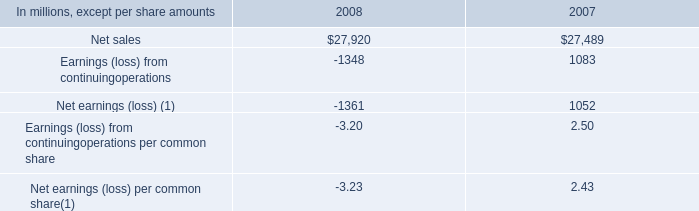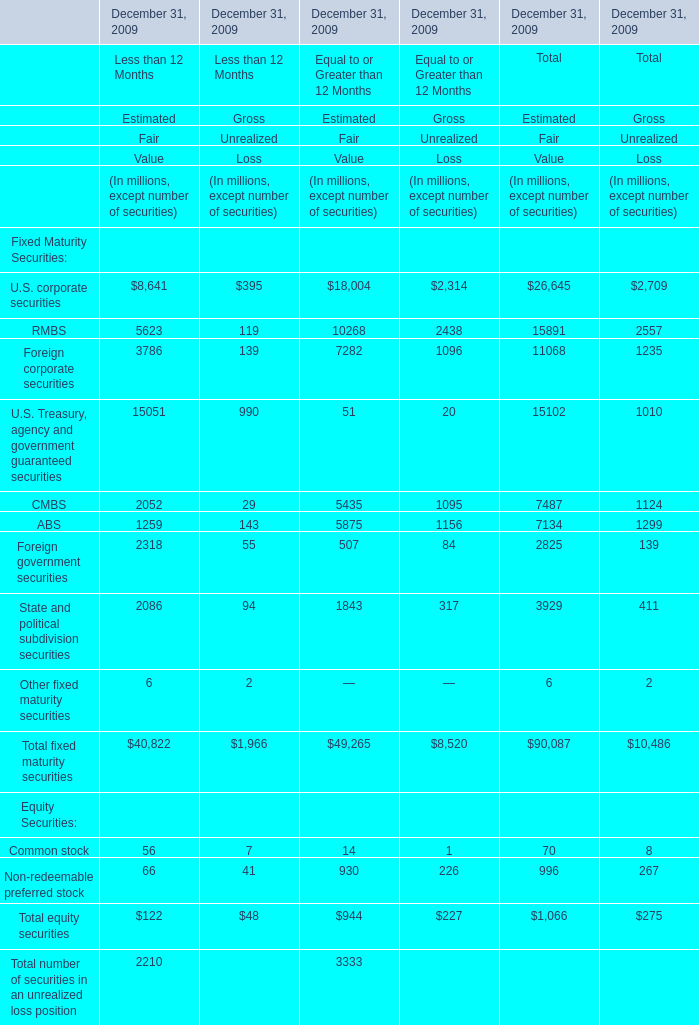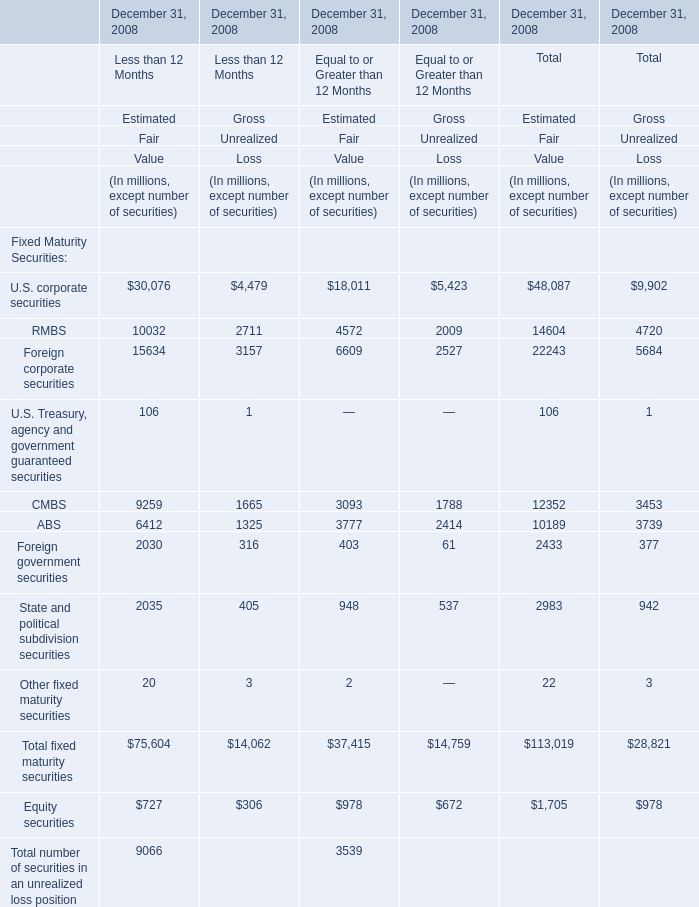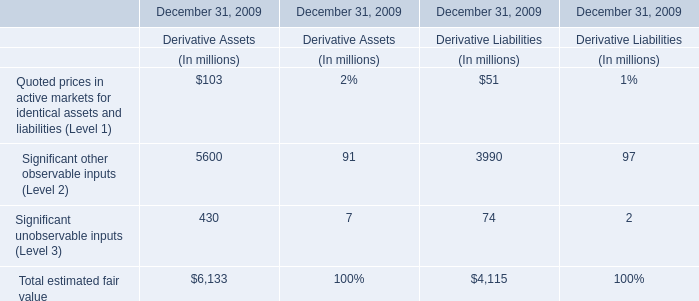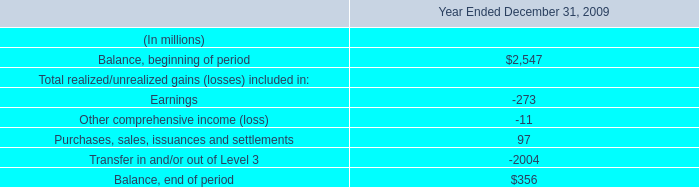What's the average Estimated Fair Value for Other fixed maturity securities for Less than 12 Months and for Equal to or Greater than 12 Months? (in million) 
Computations: ((20 + 2) / 2)
Answer: 11.0. 